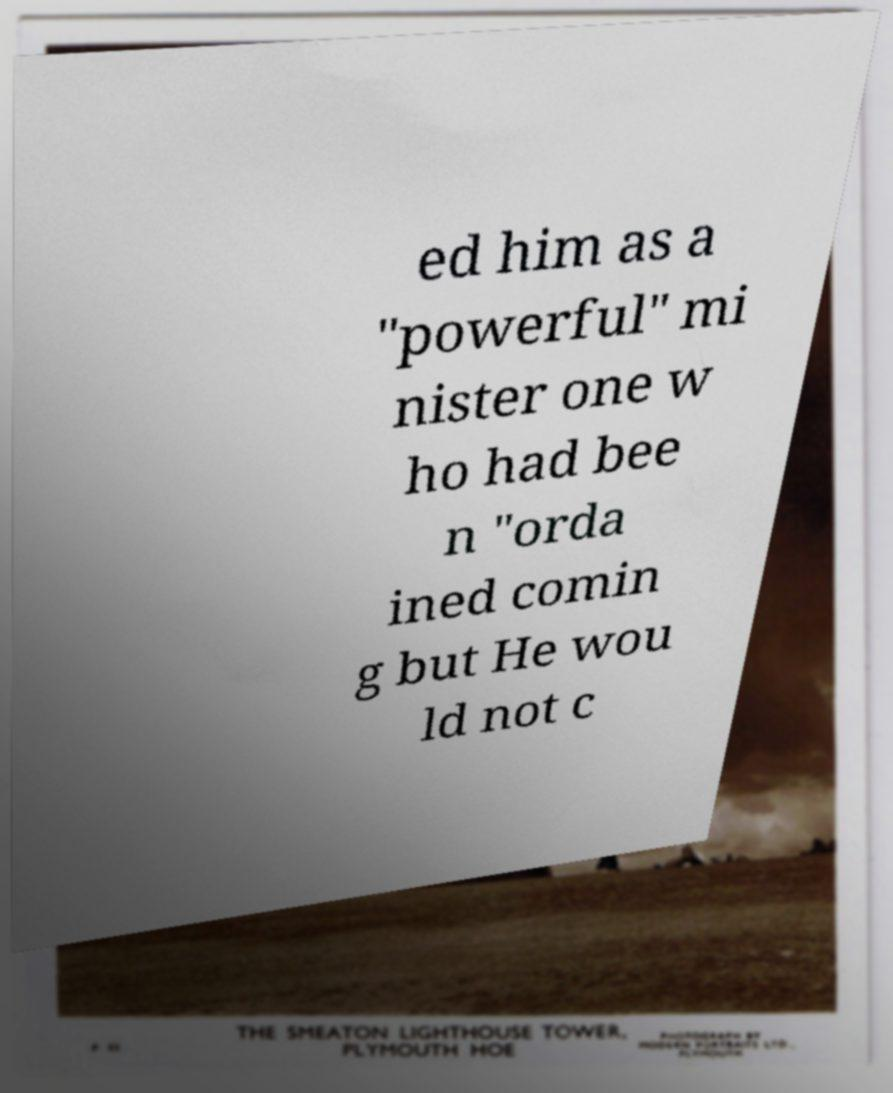Could you assist in decoding the text presented in this image and type it out clearly? ed him as a "powerful" mi nister one w ho had bee n "orda ined comin g but He wou ld not c 